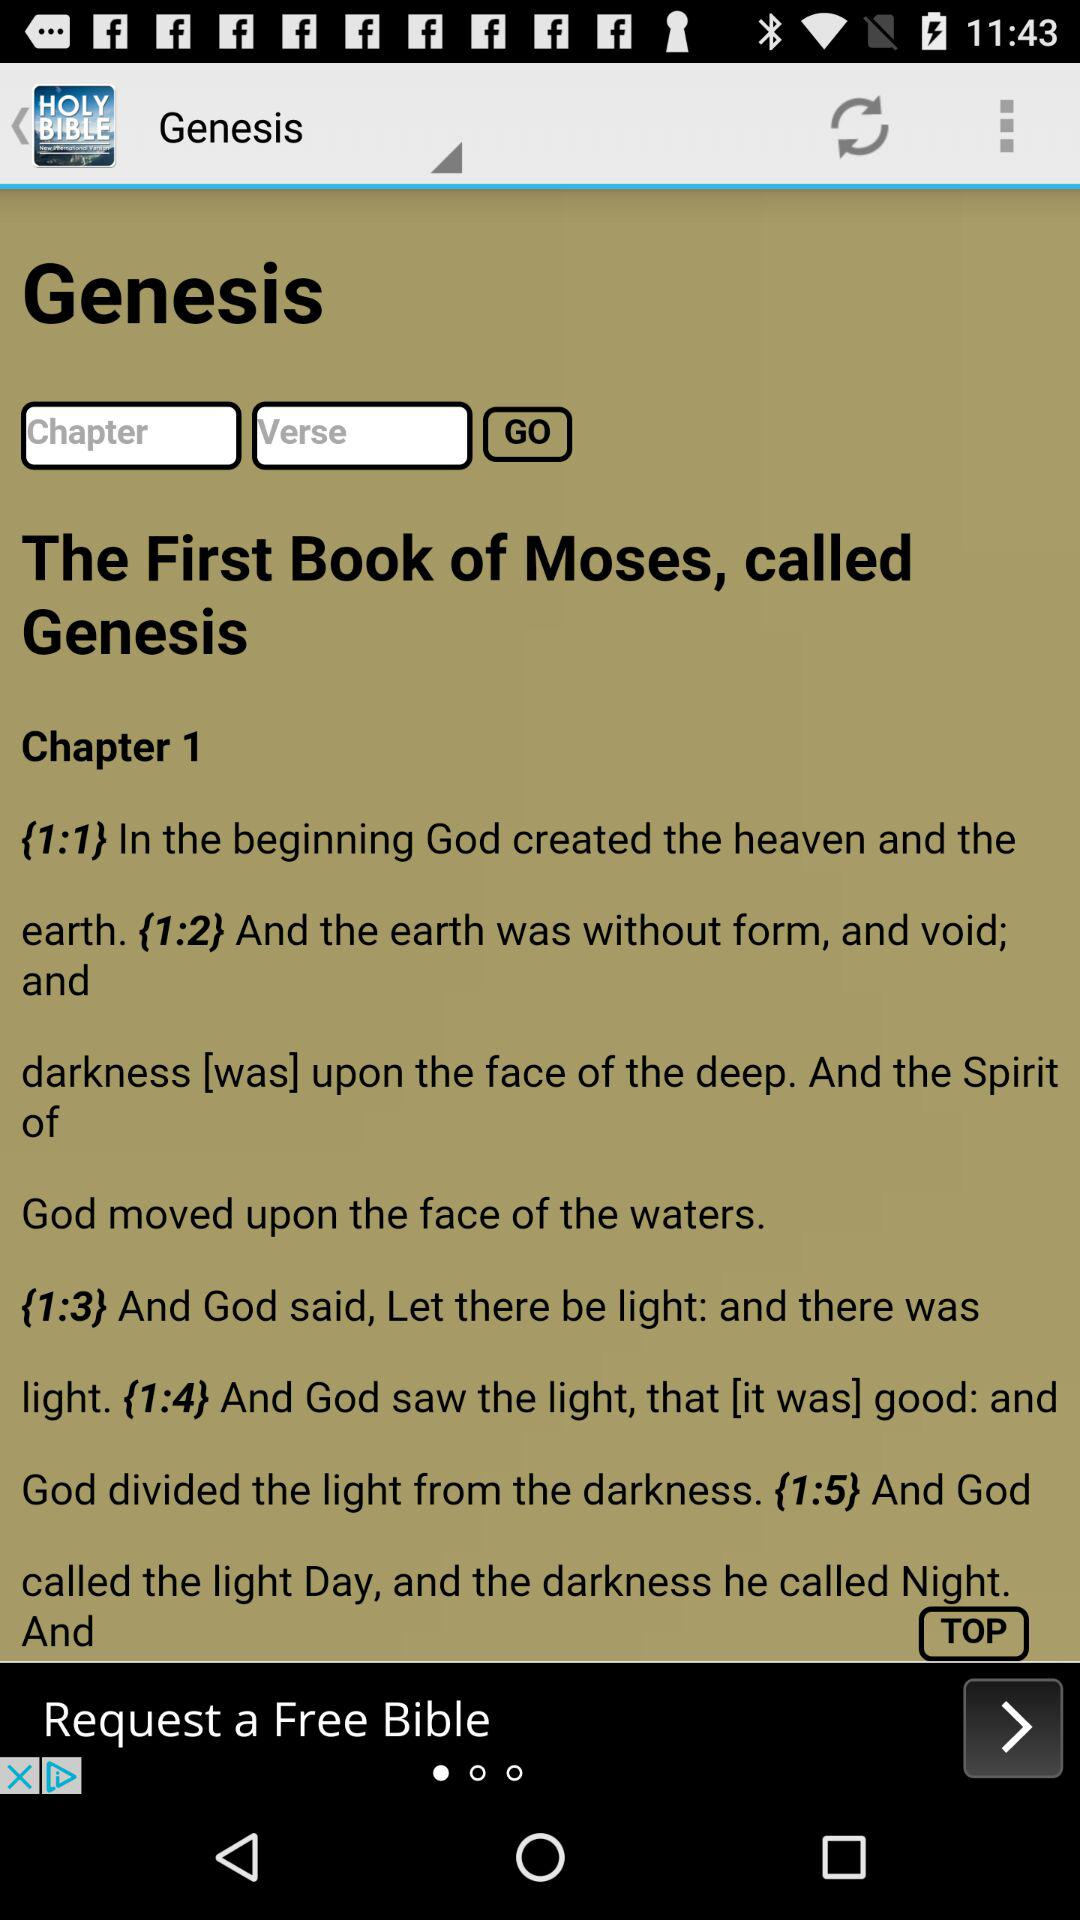What is the chapter number? The chapter number is 1. 